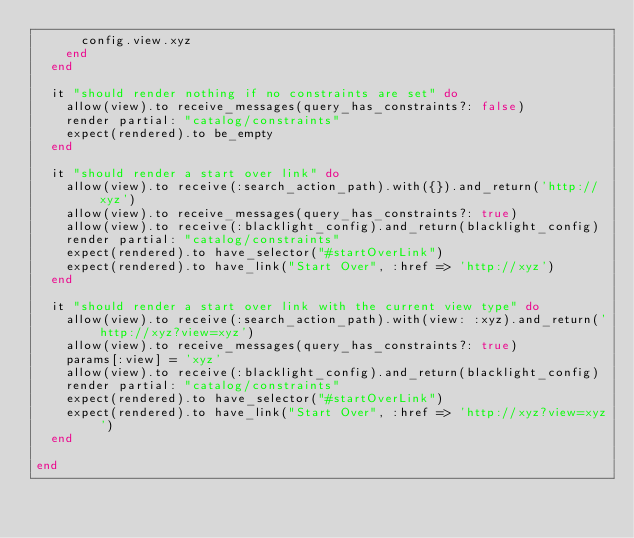<code> <loc_0><loc_0><loc_500><loc_500><_Ruby_>      config.view.xyz
    end
  end

  it "should render nothing if no constraints are set" do
    allow(view).to receive_messages(query_has_constraints?: false)
    render partial: "catalog/constraints"
    expect(rendered).to be_empty
  end

  it "should render a start over link" do
    allow(view).to receive(:search_action_path).with({}).and_return('http://xyz')
    allow(view).to receive_messages(query_has_constraints?: true)
    allow(view).to receive(:blacklight_config).and_return(blacklight_config)
    render partial: "catalog/constraints"
    expect(rendered).to have_selector("#startOverLink")
    expect(rendered).to have_link("Start Over", :href => 'http://xyz')
  end

  it "should render a start over link with the current view type" do
    allow(view).to receive(:search_action_path).with(view: :xyz).and_return('http://xyz?view=xyz')
    allow(view).to receive_messages(query_has_constraints?: true)
    params[:view] = 'xyz'
    allow(view).to receive(:blacklight_config).and_return(blacklight_config)
    render partial: "catalog/constraints"
    expect(rendered).to have_selector("#startOverLink")
    expect(rendered).to have_link("Start Over", :href => 'http://xyz?view=xyz')
  end

end
</code> 